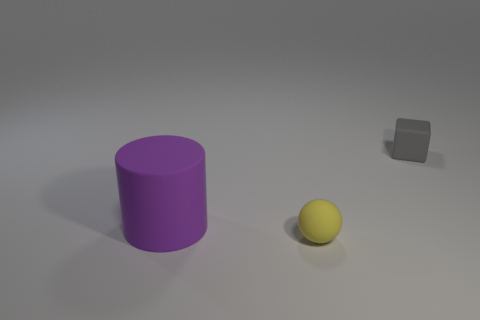Add 3 tiny balls. How many objects exist? 6 Subtract all cubes. How many objects are left? 2 Add 1 large green spheres. How many large green spheres exist? 1 Subtract 0 blue cylinders. How many objects are left? 3 Subtract all tiny yellow rubber objects. Subtract all small rubber spheres. How many objects are left? 1 Add 2 tiny rubber blocks. How many tiny rubber blocks are left? 3 